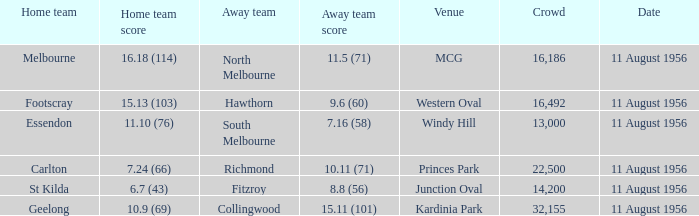Which home team currently holds a score of 16.18 (114)? Melbourne. 